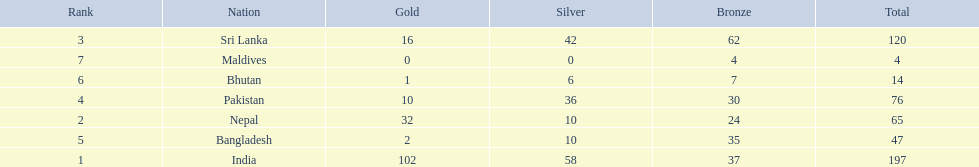How many gold medals were won by the teams? 102, 32, 16, 10, 2, 1, 0. What country won no gold medals? Maldives. 